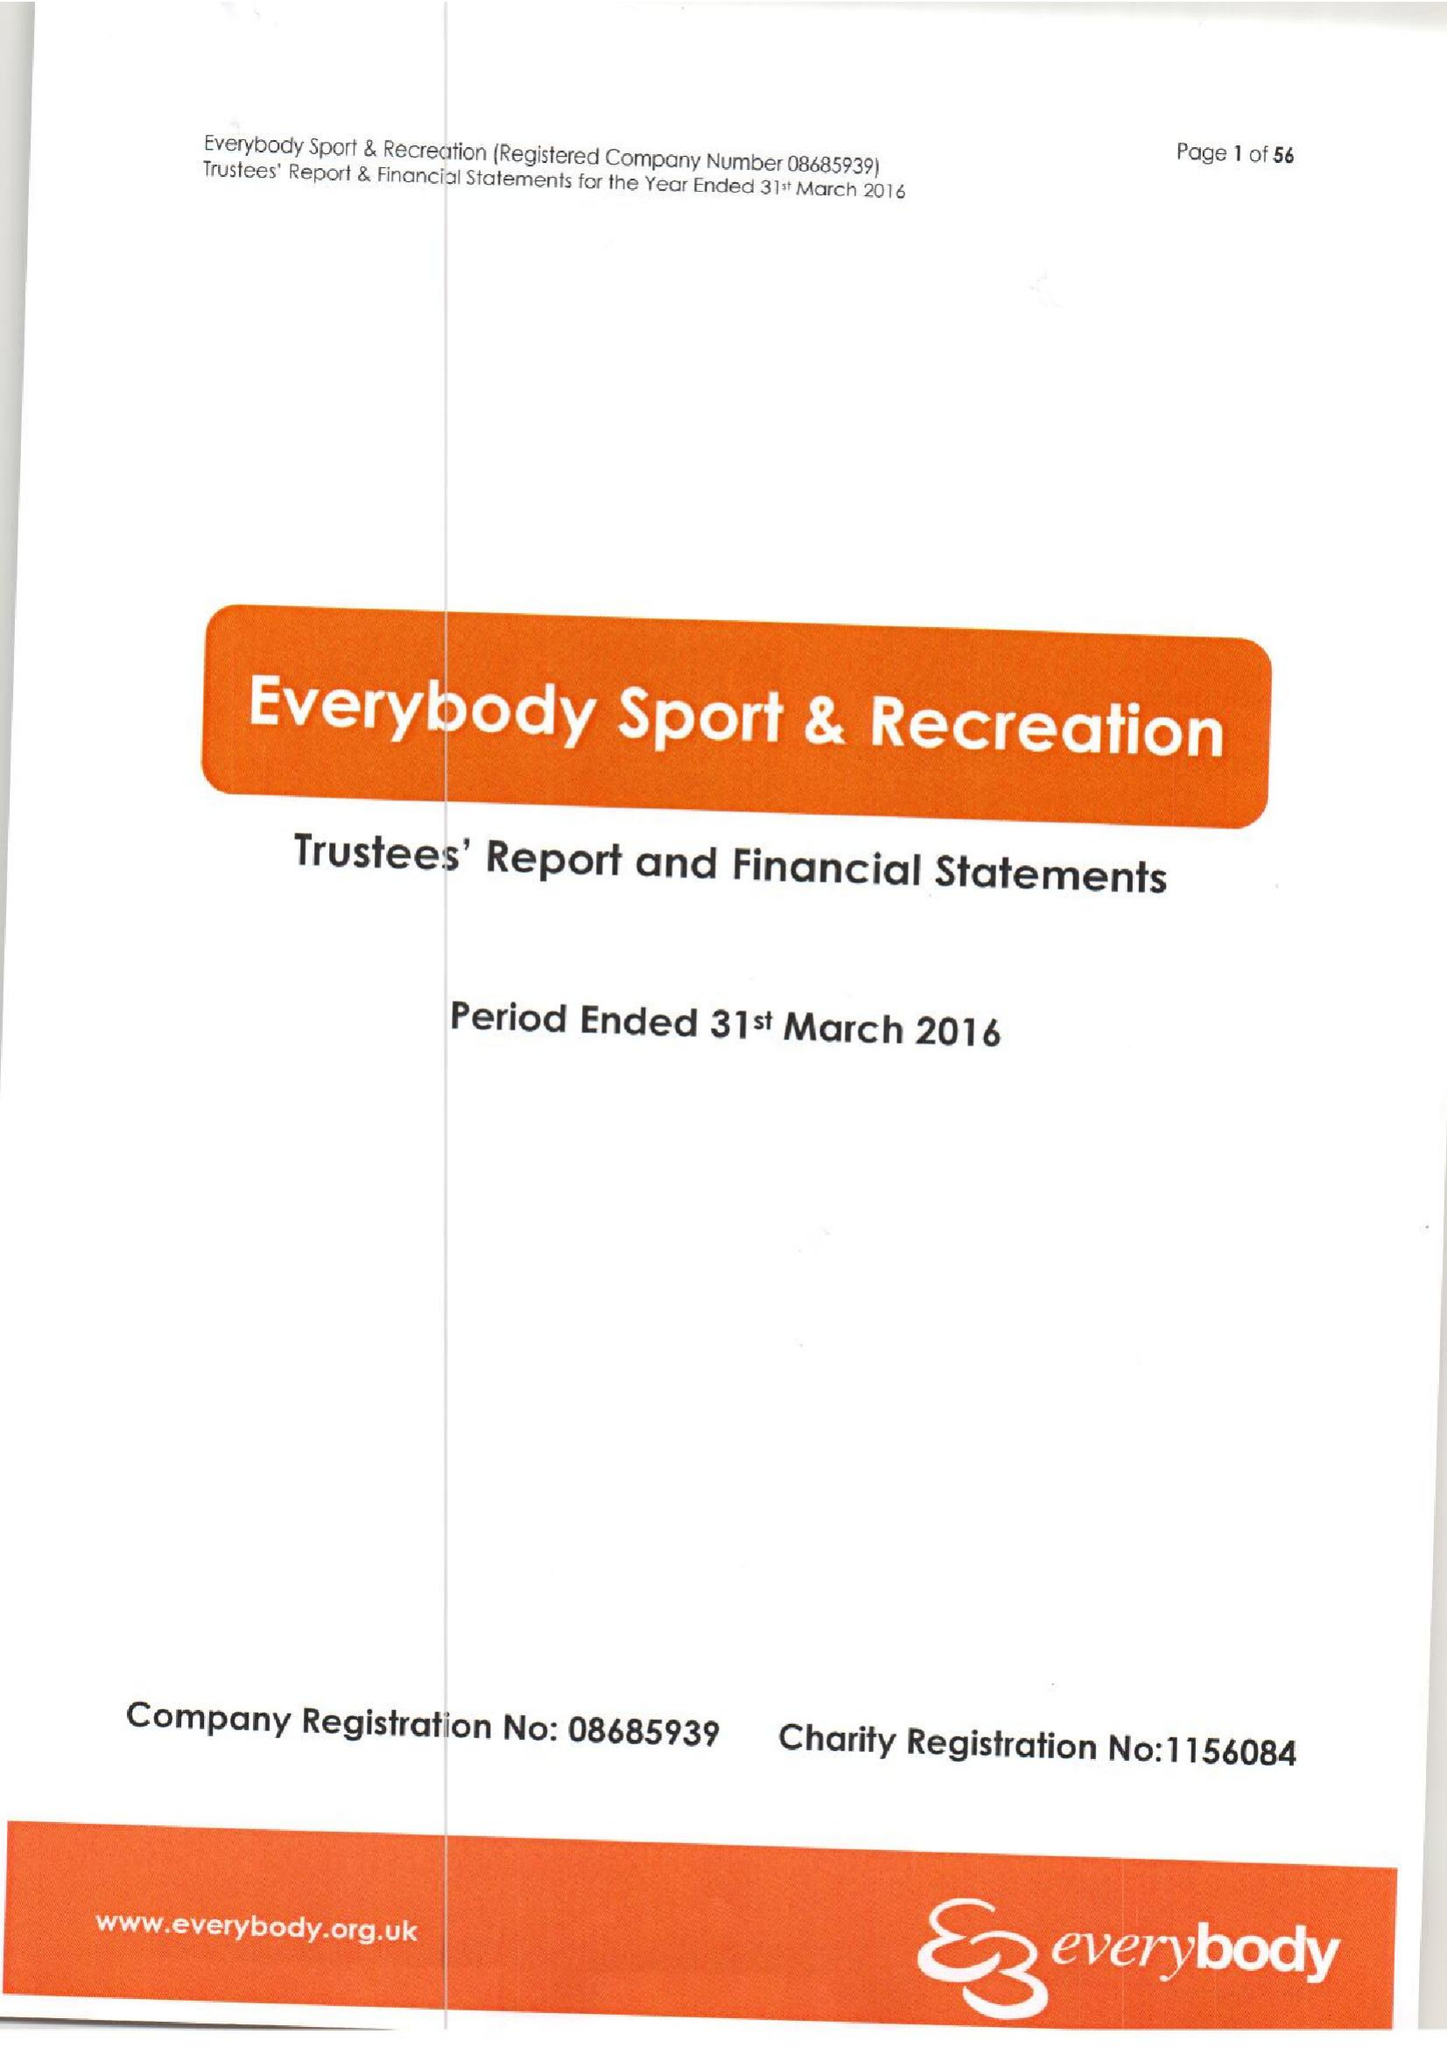What is the value for the address__street_line?
Answer the question using a single word or phrase. STATION ROAD 